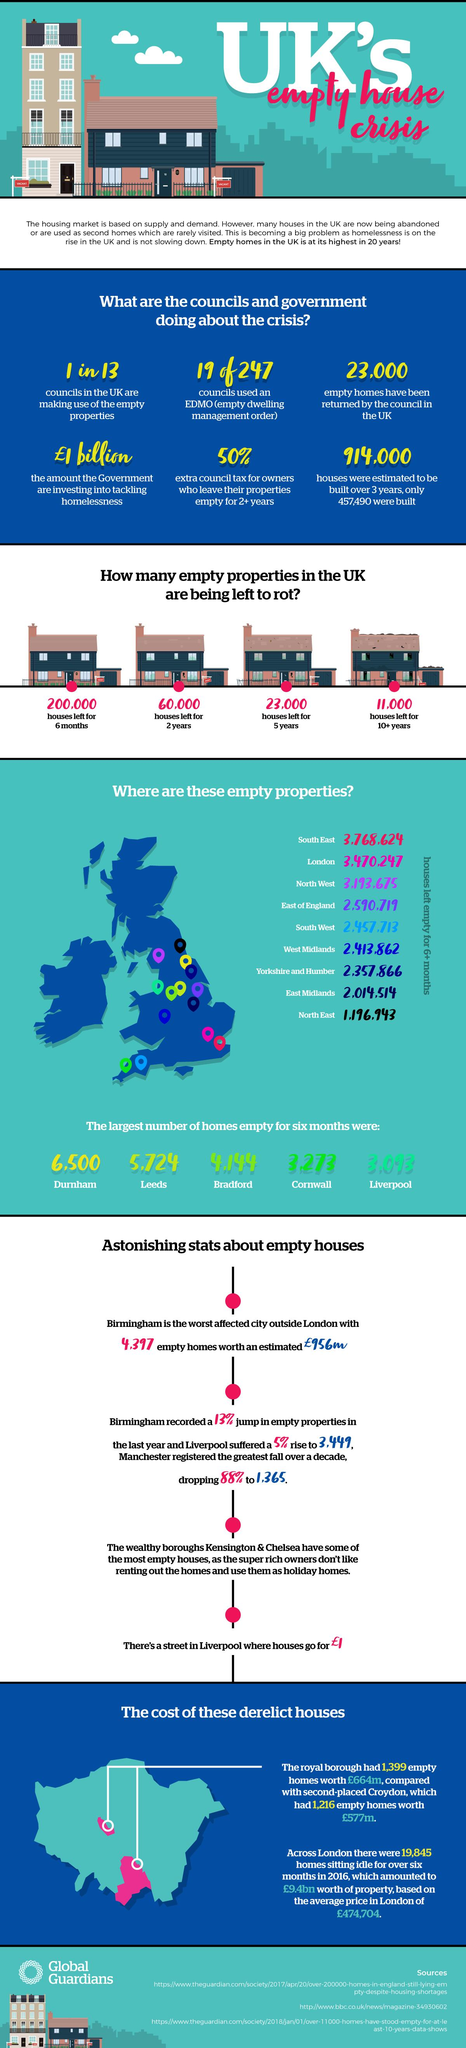Specify some key components in this picture. According to sources, there are two locations in the extreme south of the United Kingdom with vacant houses. There are approximately 3,273 houses in Cornwall that have been left empty for the past half a year. It is estimated that approximately 11,000 houses in the UK have been left empty for more than 10 years. In the United Kingdom, an estimated 23,000 houses have remained empty for the past five years. According to recent data, the East Midlands in the United Kingdom has the second lowest number of vacant homes. 